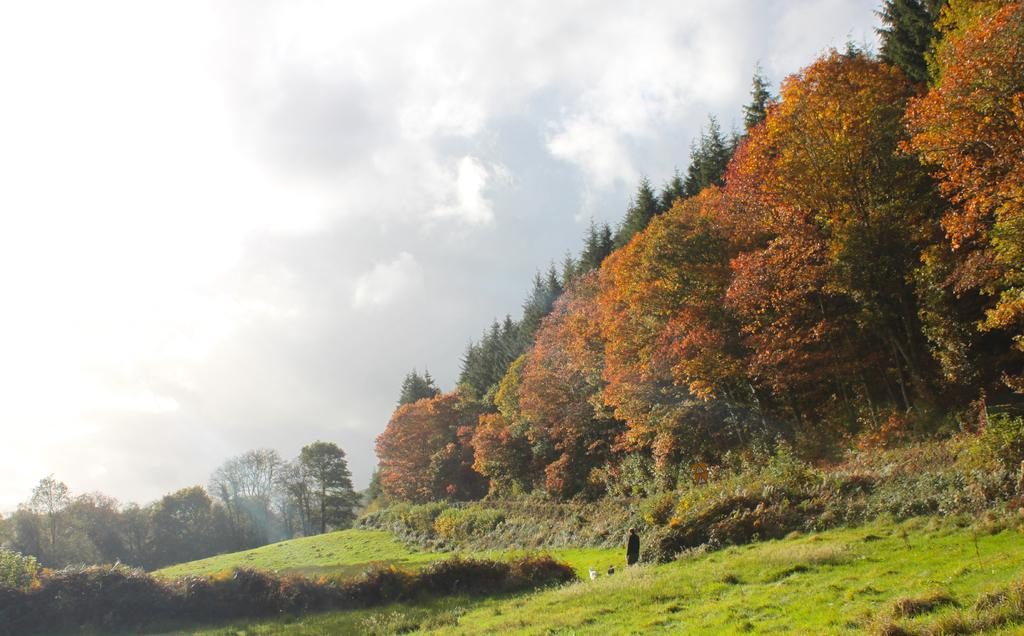What is located at the bottom of the image? There are plants at the bottom of the image. What can be seen in the image besides the plants? A person is standing in the image. What type of vegetation is present on the ground? Trees are present on the ground. What is visible in the sky in the background of the image? Clouds are visible in the sky in the background of the image. What type of mask is the person wearing in the image? There is no mask visible on the person in the image. What type of apparel is the person wearing in the image? The provided facts do not mention any specific apparel worn by the person in the image. 